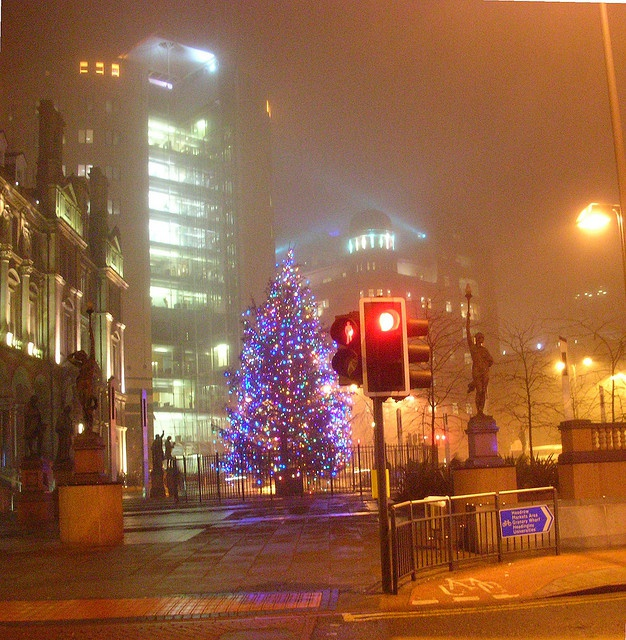Describe the objects in this image and their specific colors. I can see traffic light in white, maroon, brown, red, and orange tones, traffic light in white, maroon, brown, and red tones, people in white, maroon, black, and purple tones, people in white, maroon, black, and gray tones, and people in white, darkgray, lightgreen, and beige tones in this image. 